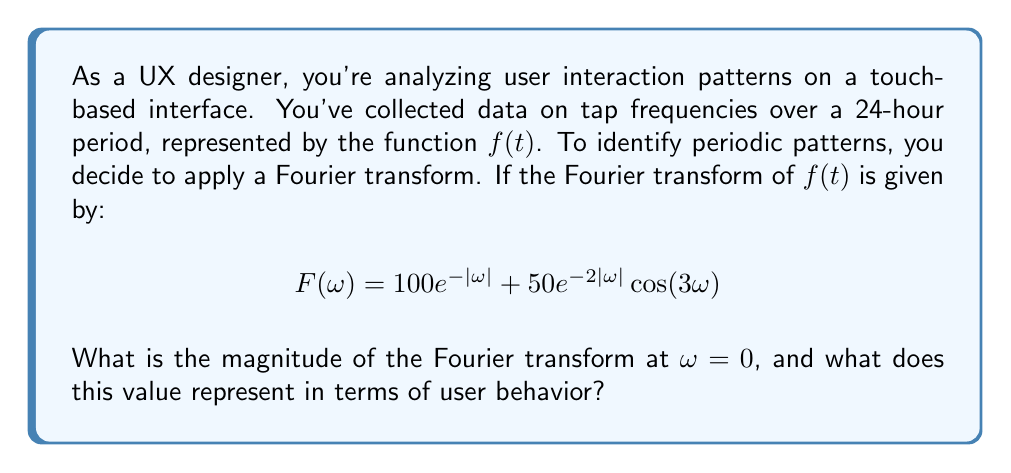Help me with this question. Let's break this down step-by-step:

1) The Fourier transform $F(\omega)$ is given as:

   $$F(\omega) = 100e^{-|\omega|} + 50e^{-2|\omega|}\cos(3\omega)$$

2) We need to find the magnitude of $F(\omega)$ at $\omega = 0$. This means we need to evaluate $|F(0)|$.

3) At $\omega = 0$:
   
   $e^{-|0|} = e^0 = 1$
   
   $e^{-2|0|} = e^0 = 1$
   
   $\cos(3 \cdot 0) = \cos(0) = 1$

4) Substituting these values:

   $$F(0) = 100 \cdot 1 + 50 \cdot 1 \cdot 1 = 100 + 50 = 150$$

5) The magnitude at $\omega = 0$ is simply this value, as it's already real:

   $$|F(0)| = 150$$

6) In terms of user behavior, the magnitude of the Fourier transform at $\omega = 0$ represents the DC component or the average value of the original function $f(t)$. 

7) In this context, it represents the average number of taps per unit time over the 24-hour period. This gives us an overall measure of how frequently users interact with the interface, regardless of any periodic patterns.
Answer: The magnitude of the Fourier transform at $\omega = 0$ is 150. This value represents the average number of taps per unit time over the 24-hour period, providing a measure of overall user interaction frequency with the interface. 